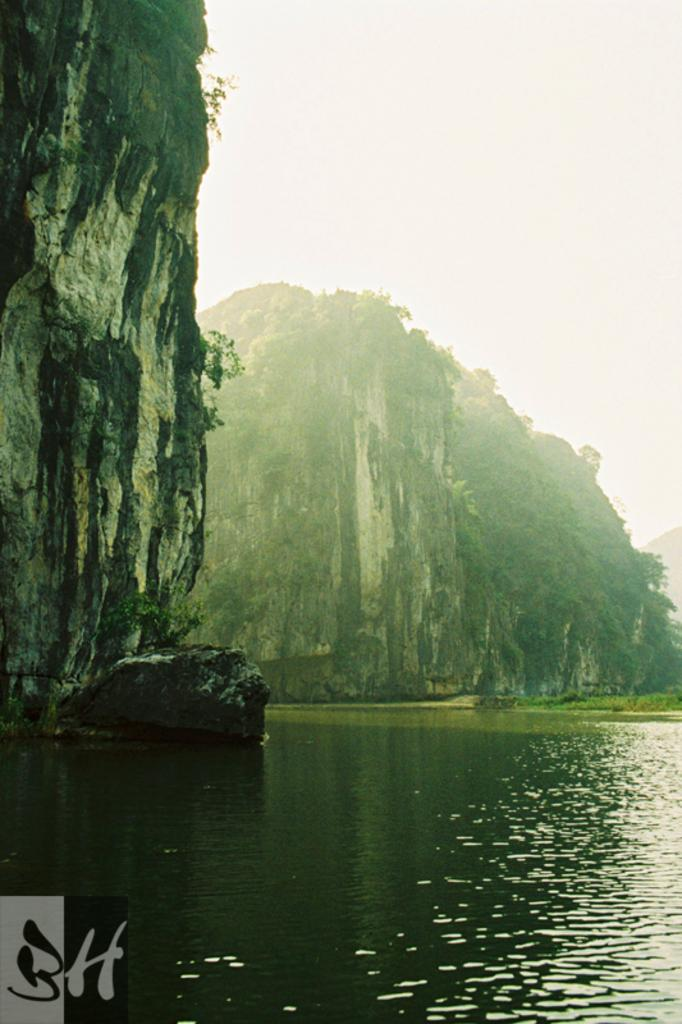What type of natural feature is present in the image? There is a river in the image. What other geographical features can be seen in the image? There are mountains with trees in the image. What is the condition of the sky in the image? The sky is clear in the image. How many rings are visible on the river in the image? There are no rings present in the image; it features a river, mountains with trees, and a clear sky. What type of heat source can be seen in the image? There is no heat source visible in the image. 